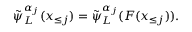Convert formula to latex. <formula><loc_0><loc_0><loc_500><loc_500>\tilde { \psi } _ { L } ^ { \alpha _ { j } } ( \boldsymbol x _ { \leq j } ) = \tilde { \psi } _ { L } ^ { \alpha _ { j } } ( F ( \boldsymbol x _ { \leq j } ) ) .</formula> 